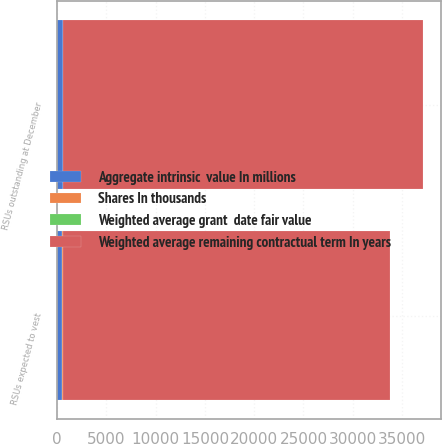<chart> <loc_0><loc_0><loc_500><loc_500><stacked_bar_chart><ecel><fcel>RSUs outstanding at December<fcel>RSUs expected to vest<nl><fcel>Weighted average remaining contractual term In years<fcel>36483<fcel>33239<nl><fcel>Shares In thousands<fcel>32.57<fcel>32.61<nl><fcel>Weighted average grant  date fair value<fcel>2.9<fcel>2.8<nl><fcel>Aggregate intrinsic  value In millions<fcel>591<fcel>538<nl></chart> 